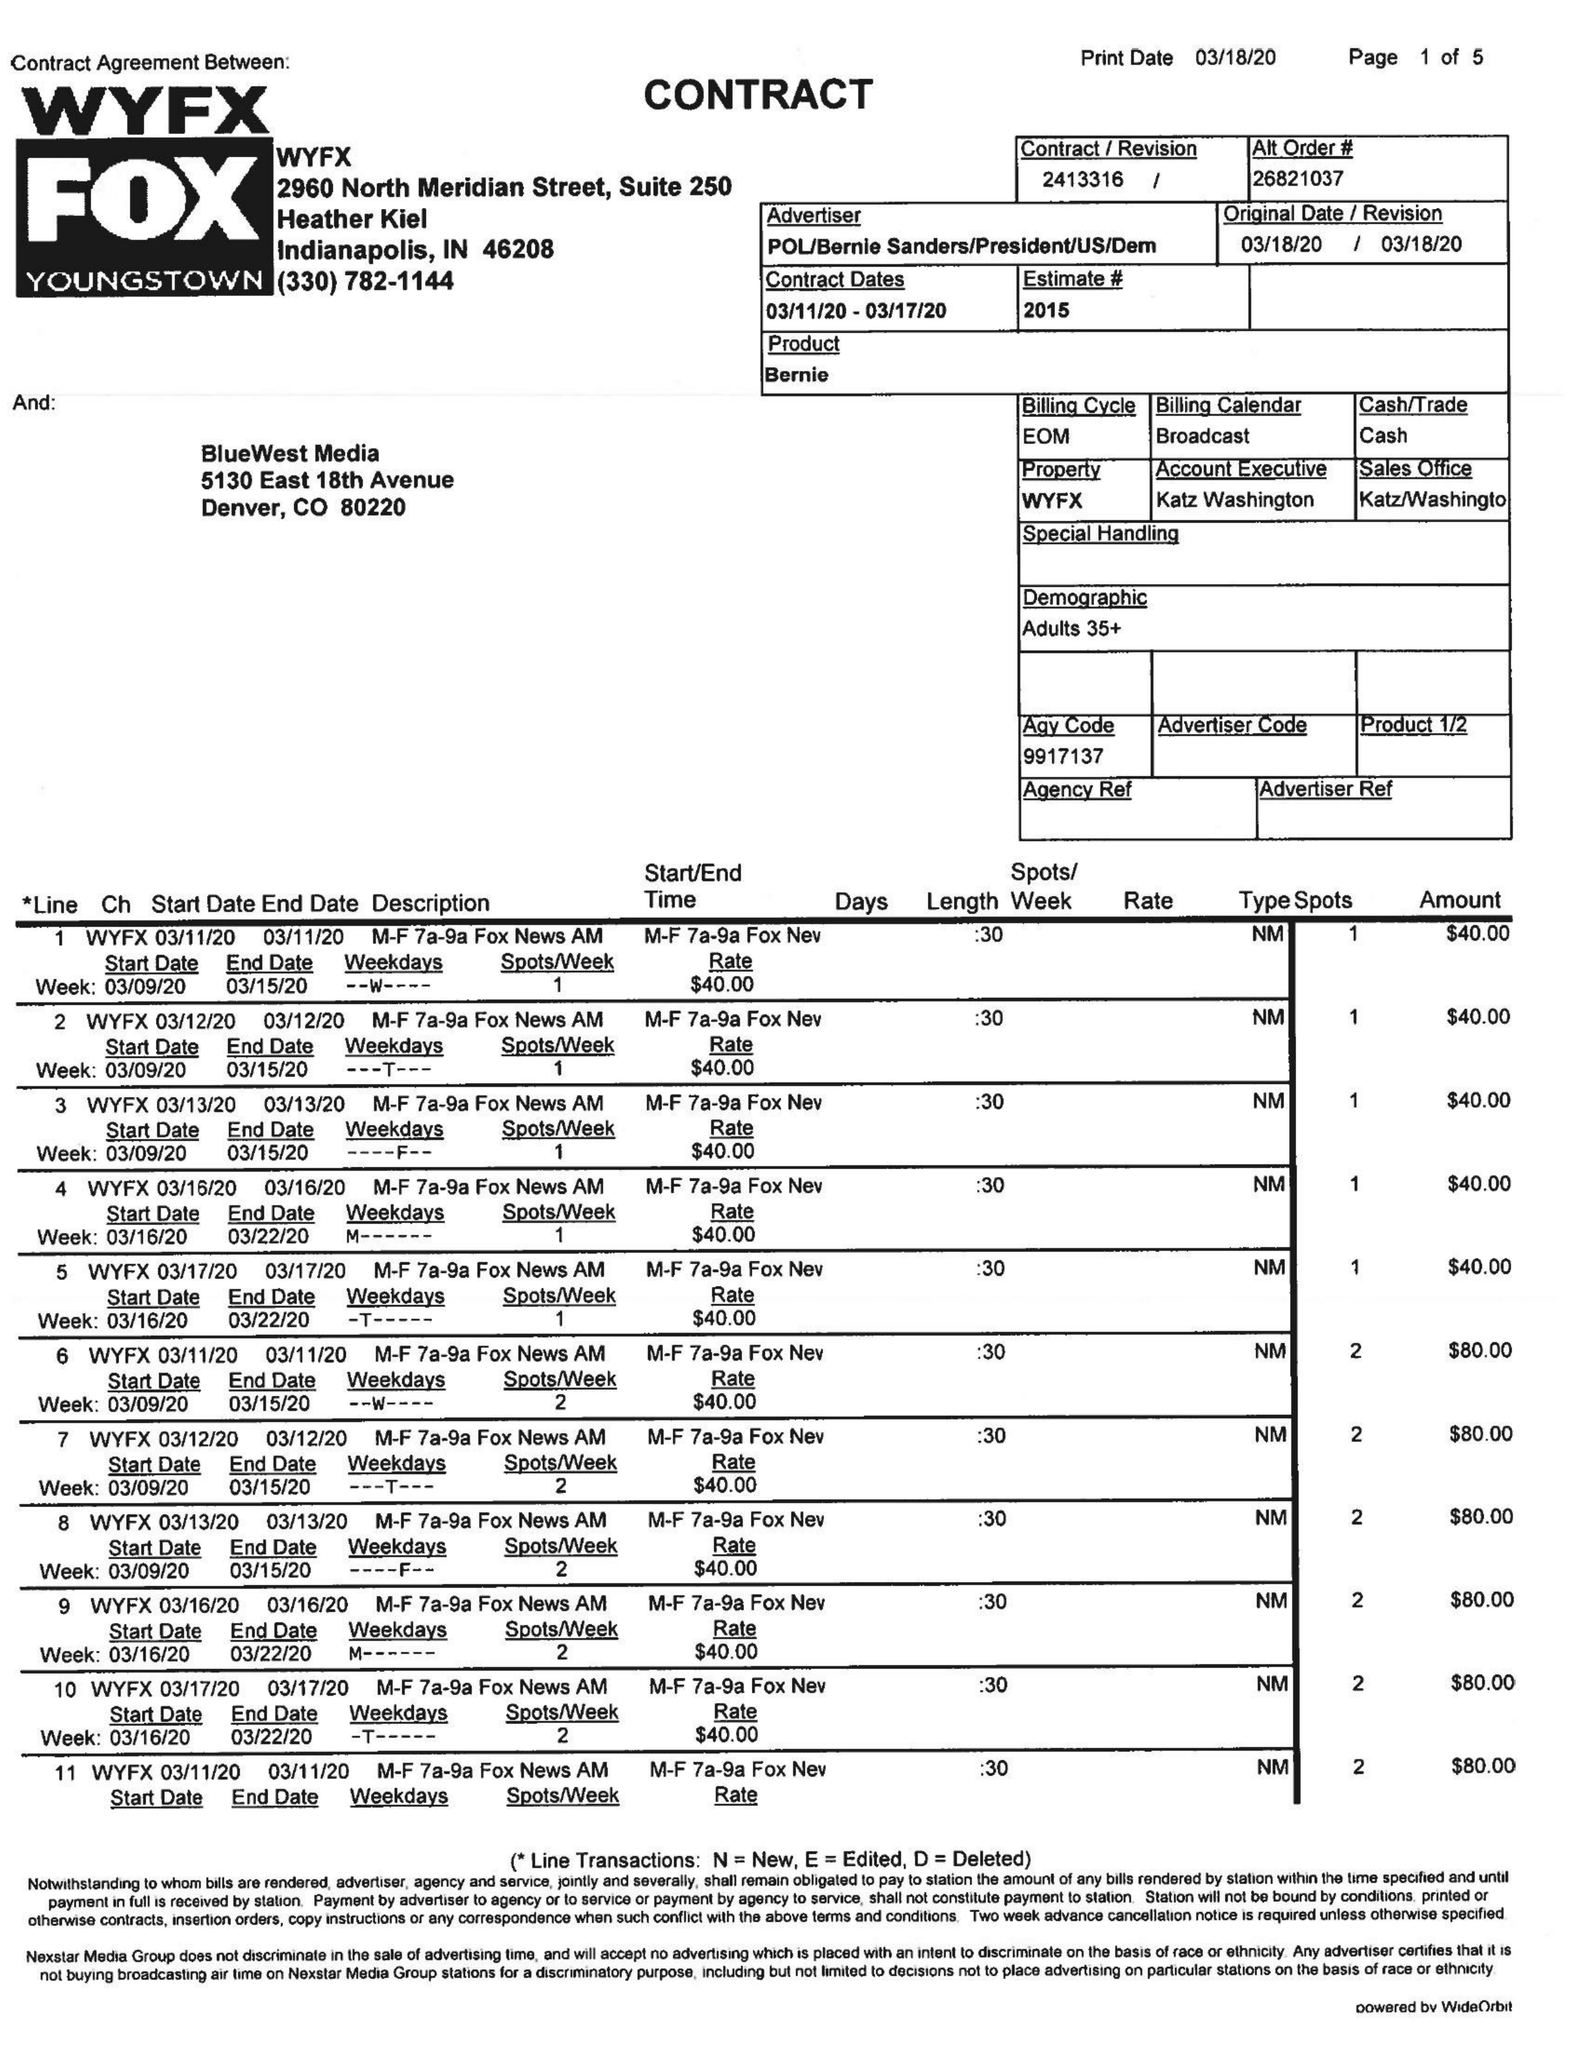What is the value for the gross_amount?
Answer the question using a single word or phrase. 5475.00 